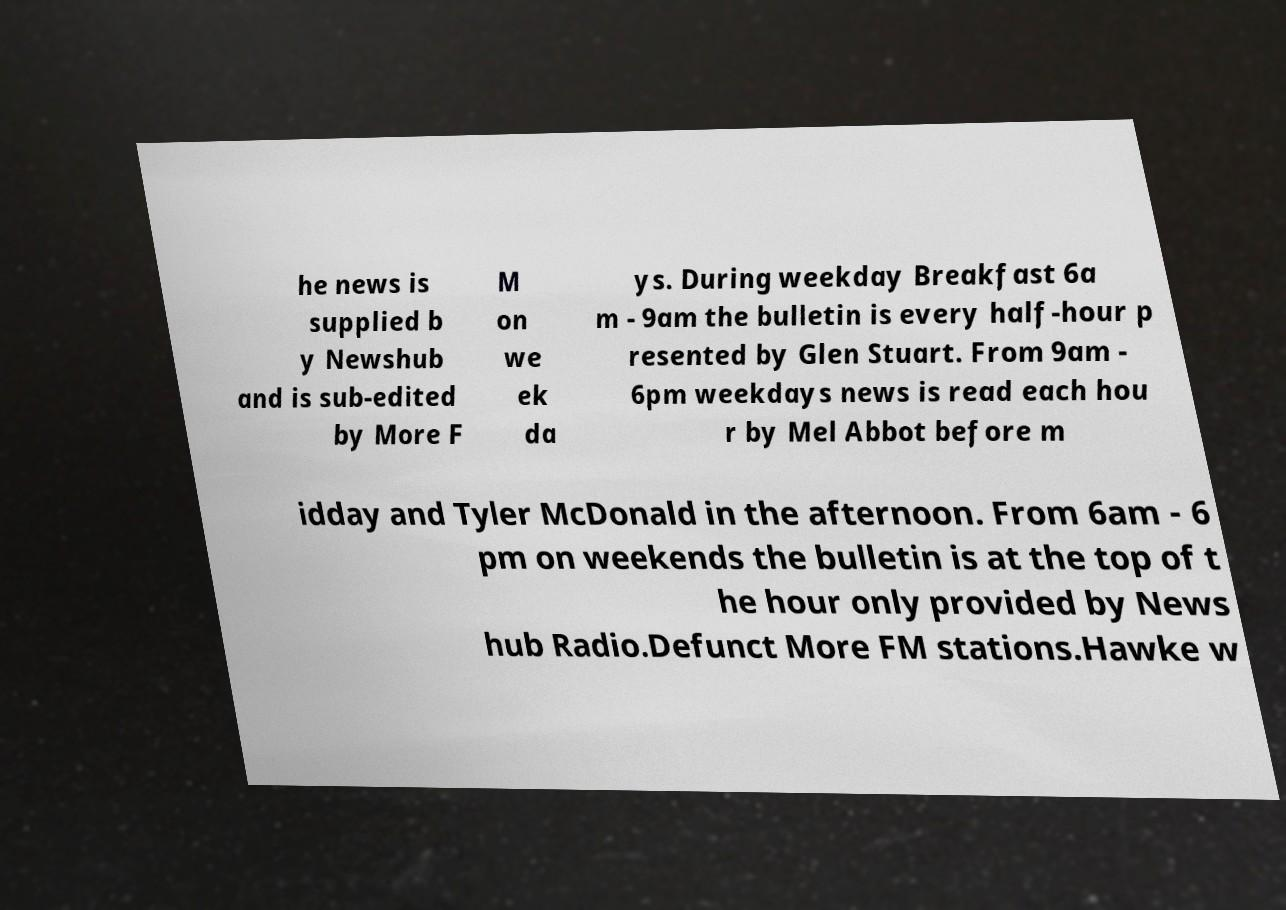Could you assist in decoding the text presented in this image and type it out clearly? he news is supplied b y Newshub and is sub-edited by More F M on we ek da ys. During weekday Breakfast 6a m - 9am the bulletin is every half-hour p resented by Glen Stuart. From 9am - 6pm weekdays news is read each hou r by Mel Abbot before m idday and Tyler McDonald in the afternoon. From 6am - 6 pm on weekends the bulletin is at the top of t he hour only provided by News hub Radio.Defunct More FM stations.Hawke w 